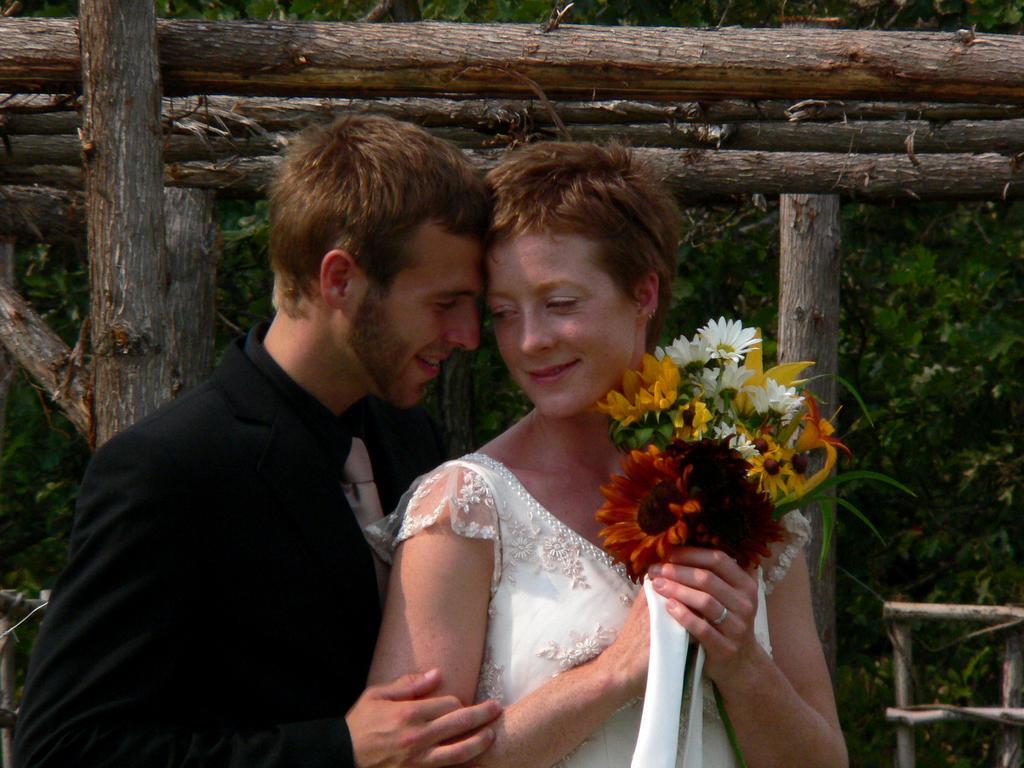Could you give a brief overview of what you see in this image? In the picture I can see a man wearing black color dress and woman wearing white color dress holding flower bouquet in her hands and in the background of the picture there are some wooden logs, trees. 